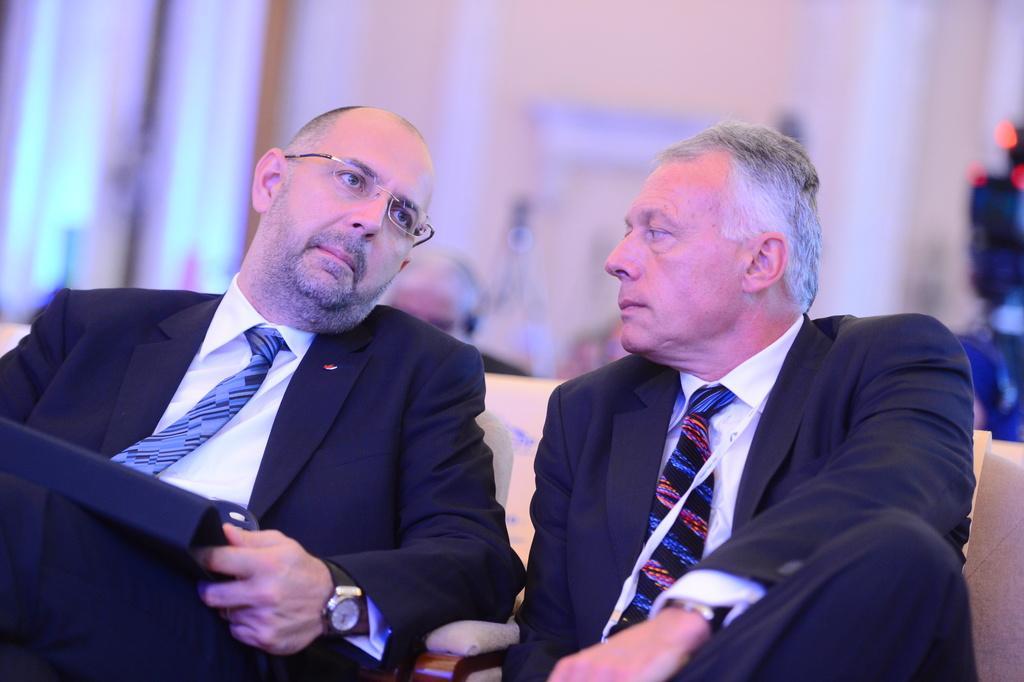Can you describe this image briefly? In the given image i can see a people wearing white and black dress and sitting on the sofa. 